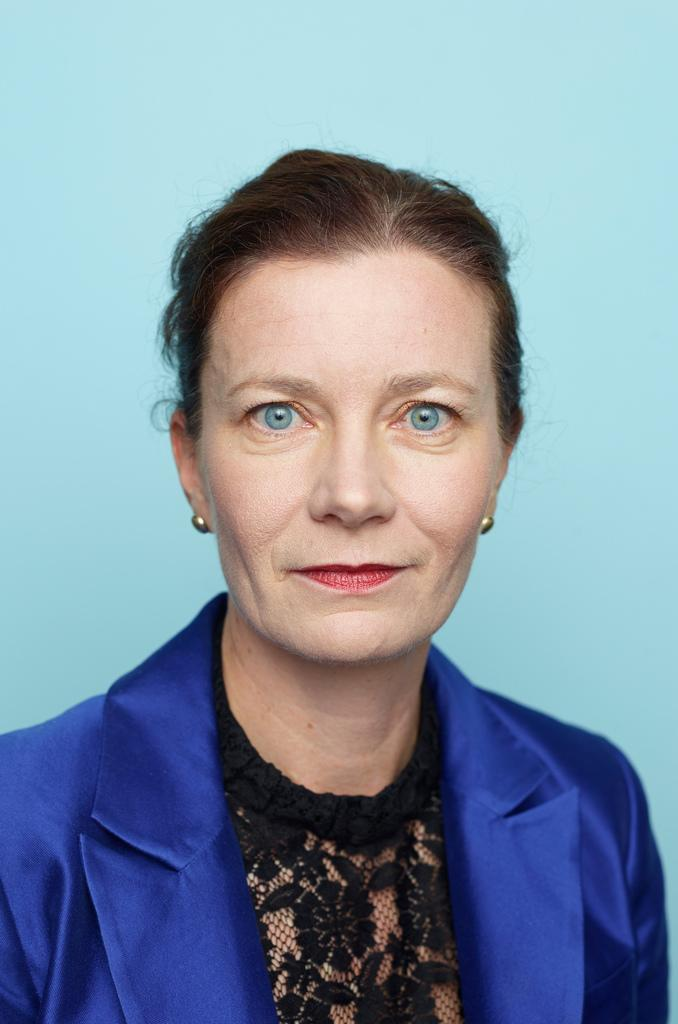Who is the main subject in the foreground of the picture? There is a woman in the foreground of the picture. What is the woman wearing in the image? The woman is wearing a purple coat. Can you describe the background of the image? There is an Italian sky blue background in the image. How many tigers can be seen playing with dolls in the image? There are no tigers or dolls present in the image. What type of clam is visible in the image? There is no clam present in the image. 